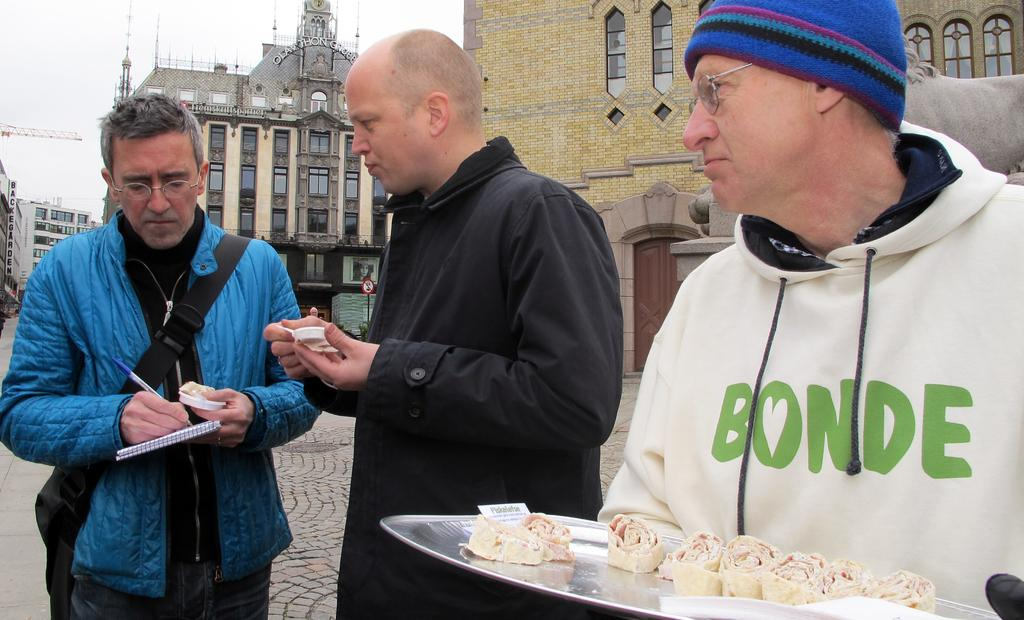How many men are standing on the road in the image? There are three men standing on the road in the image. What can be seen on the tray in the image? There is a tray with food items in the image. What stationary objects are present in the image? A book and a pen are visible in the image. What is being used to carry items in the image? A bag is visible in the image. What type of signage is present in the image? There is a signboard in the image. What type of structures are visible in the image? Buildings with windows are present in the image. What is visible in the background of the image? The sky is visible in the background of the image. What type of note is the goose holding in the image? There is no goose present in the image, and therefore no note can be held by a goose. 